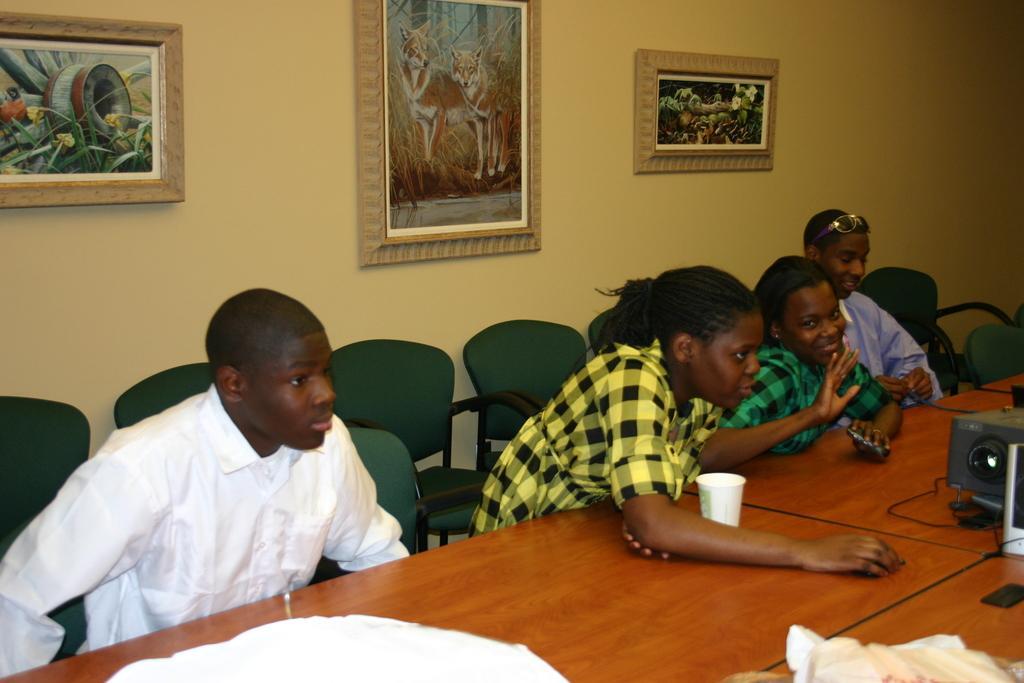How would you summarize this image in a sentence or two? In the picture we can see some people are sitting on the chairs near the table. On the table we can find a glass, a projector. In the background we can see a wall and photo frame. 